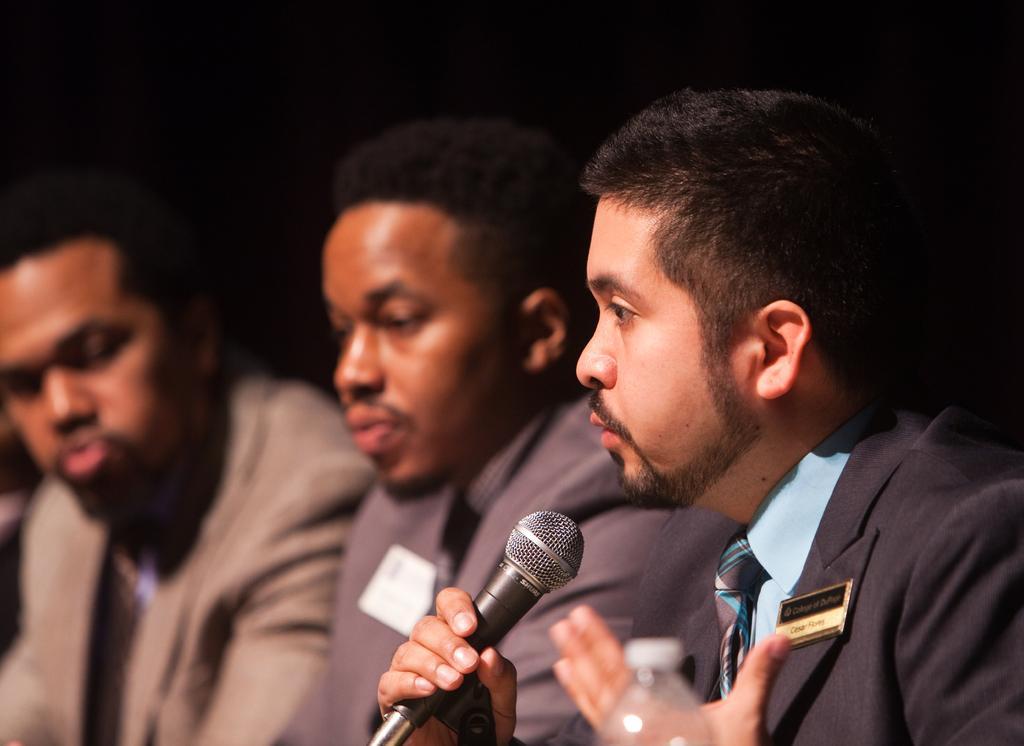Please provide a concise description of this image. In this image, There are some people siting and in the right side there is a man holding a microphone which is in black color he is speaking a microphone. 